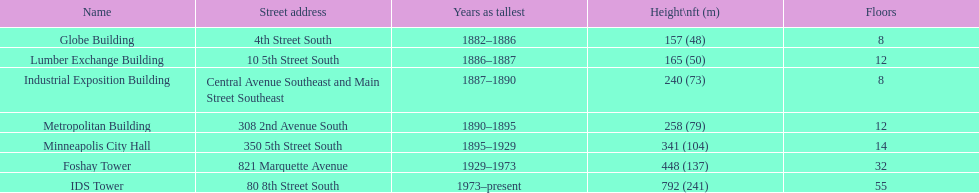After ids tower what is the second tallest building in minneapolis? Foshay Tower. 